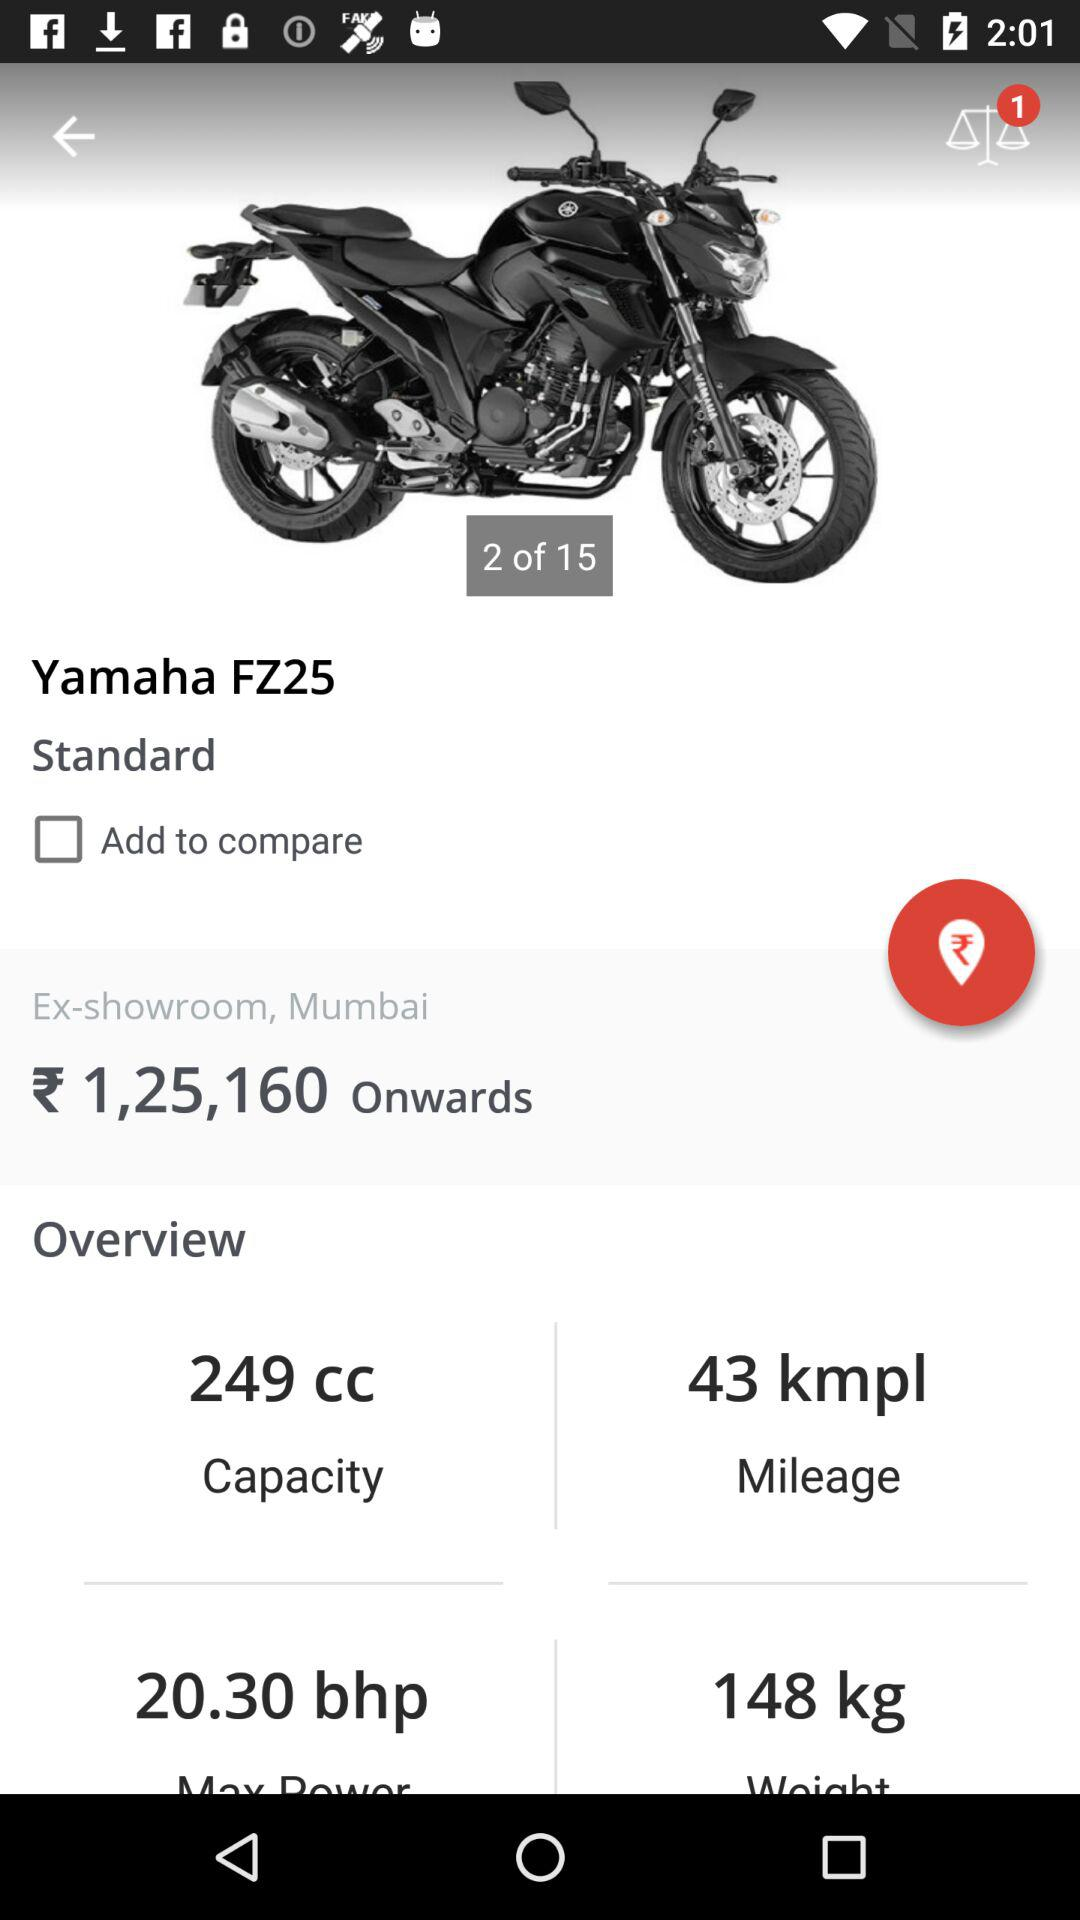How many kilometers per liter does the Yamaha FZ25 get?
Answer the question using a single word or phrase. 43 kmpl 